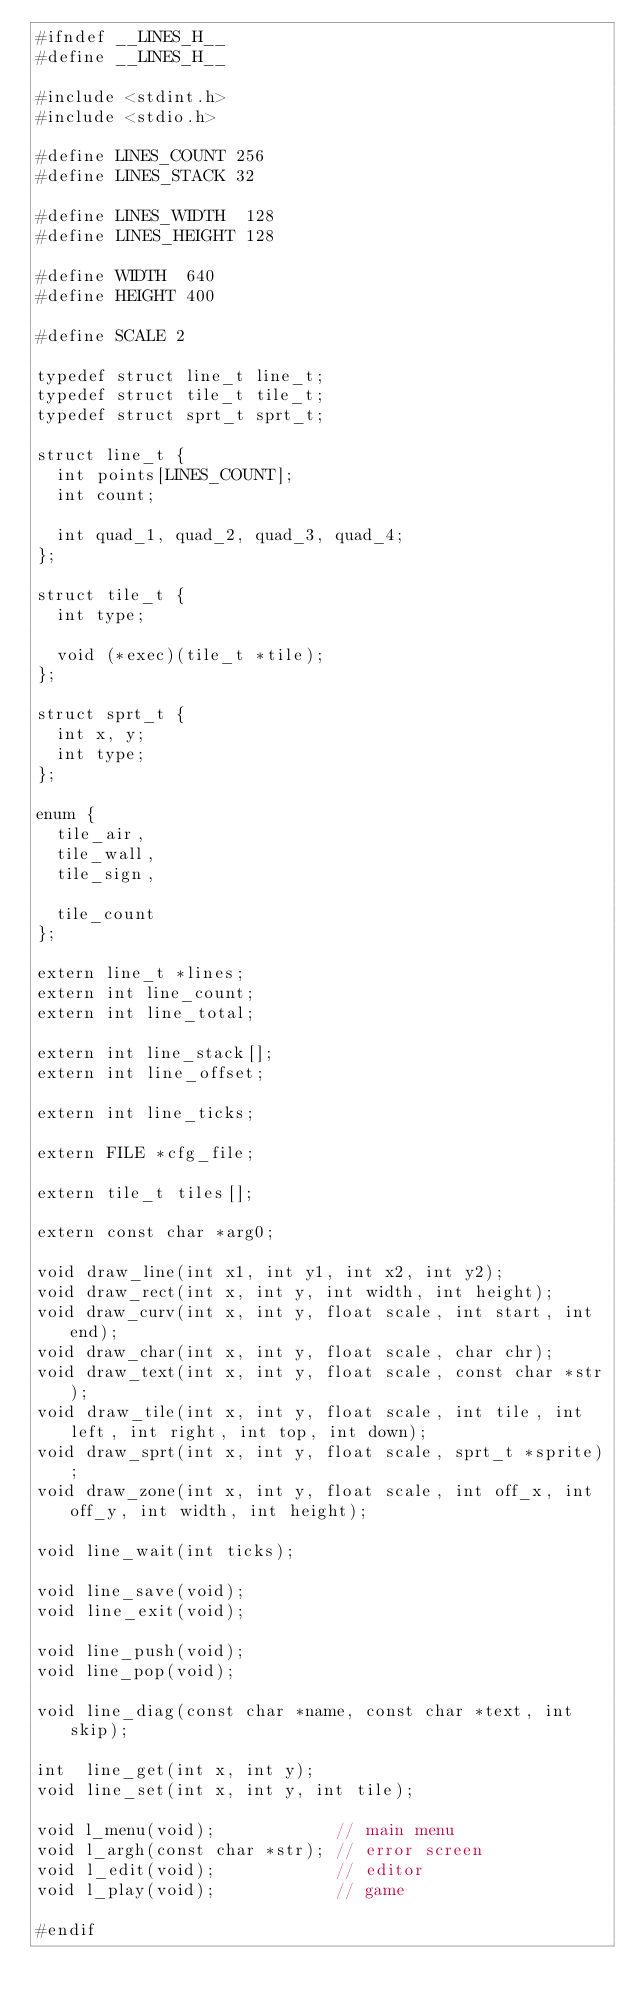Convert code to text. <code><loc_0><loc_0><loc_500><loc_500><_C_>#ifndef __LINES_H__
#define __LINES_H__

#include <stdint.h>
#include <stdio.h>

#define LINES_COUNT 256
#define LINES_STACK 32

#define LINES_WIDTH  128
#define LINES_HEIGHT 128

#define WIDTH  640
#define HEIGHT 400

#define SCALE 2

typedef struct line_t line_t;
typedef struct tile_t tile_t;
typedef struct sprt_t sprt_t;

struct line_t {
  int points[LINES_COUNT];
  int count;
  
  int quad_1, quad_2, quad_3, quad_4;
};

struct tile_t {
  int type;
  
  void (*exec)(tile_t *tile);
};

struct sprt_t {
  int x, y;
  int type;
};

enum {
  tile_air,
  tile_wall,
  tile_sign,
  
  tile_count
};

extern line_t *lines;
extern int line_count;
extern int line_total;

extern int line_stack[];
extern int line_offset;

extern int line_ticks;

extern FILE *cfg_file;

extern tile_t tiles[];

extern const char *arg0;

void draw_line(int x1, int y1, int x2, int y2);
void draw_rect(int x, int y, int width, int height);
void draw_curv(int x, int y, float scale, int start, int end);
void draw_char(int x, int y, float scale, char chr);
void draw_text(int x, int y, float scale, const char *str);
void draw_tile(int x, int y, float scale, int tile, int left, int right, int top, int down);
void draw_sprt(int x, int y, float scale, sprt_t *sprite);
void draw_zone(int x, int y, float scale, int off_x, int off_y, int width, int height);

void line_wait(int ticks);

void line_save(void);
void line_exit(void);

void line_push(void);
void line_pop(void);

void line_diag(const char *name, const char *text, int skip);

int  line_get(int x, int y);
void line_set(int x, int y, int tile);

void l_menu(void);            // main menu
void l_argh(const char *str); // error screen
void l_edit(void);            // editor
void l_play(void);            // game

#endif
</code> 